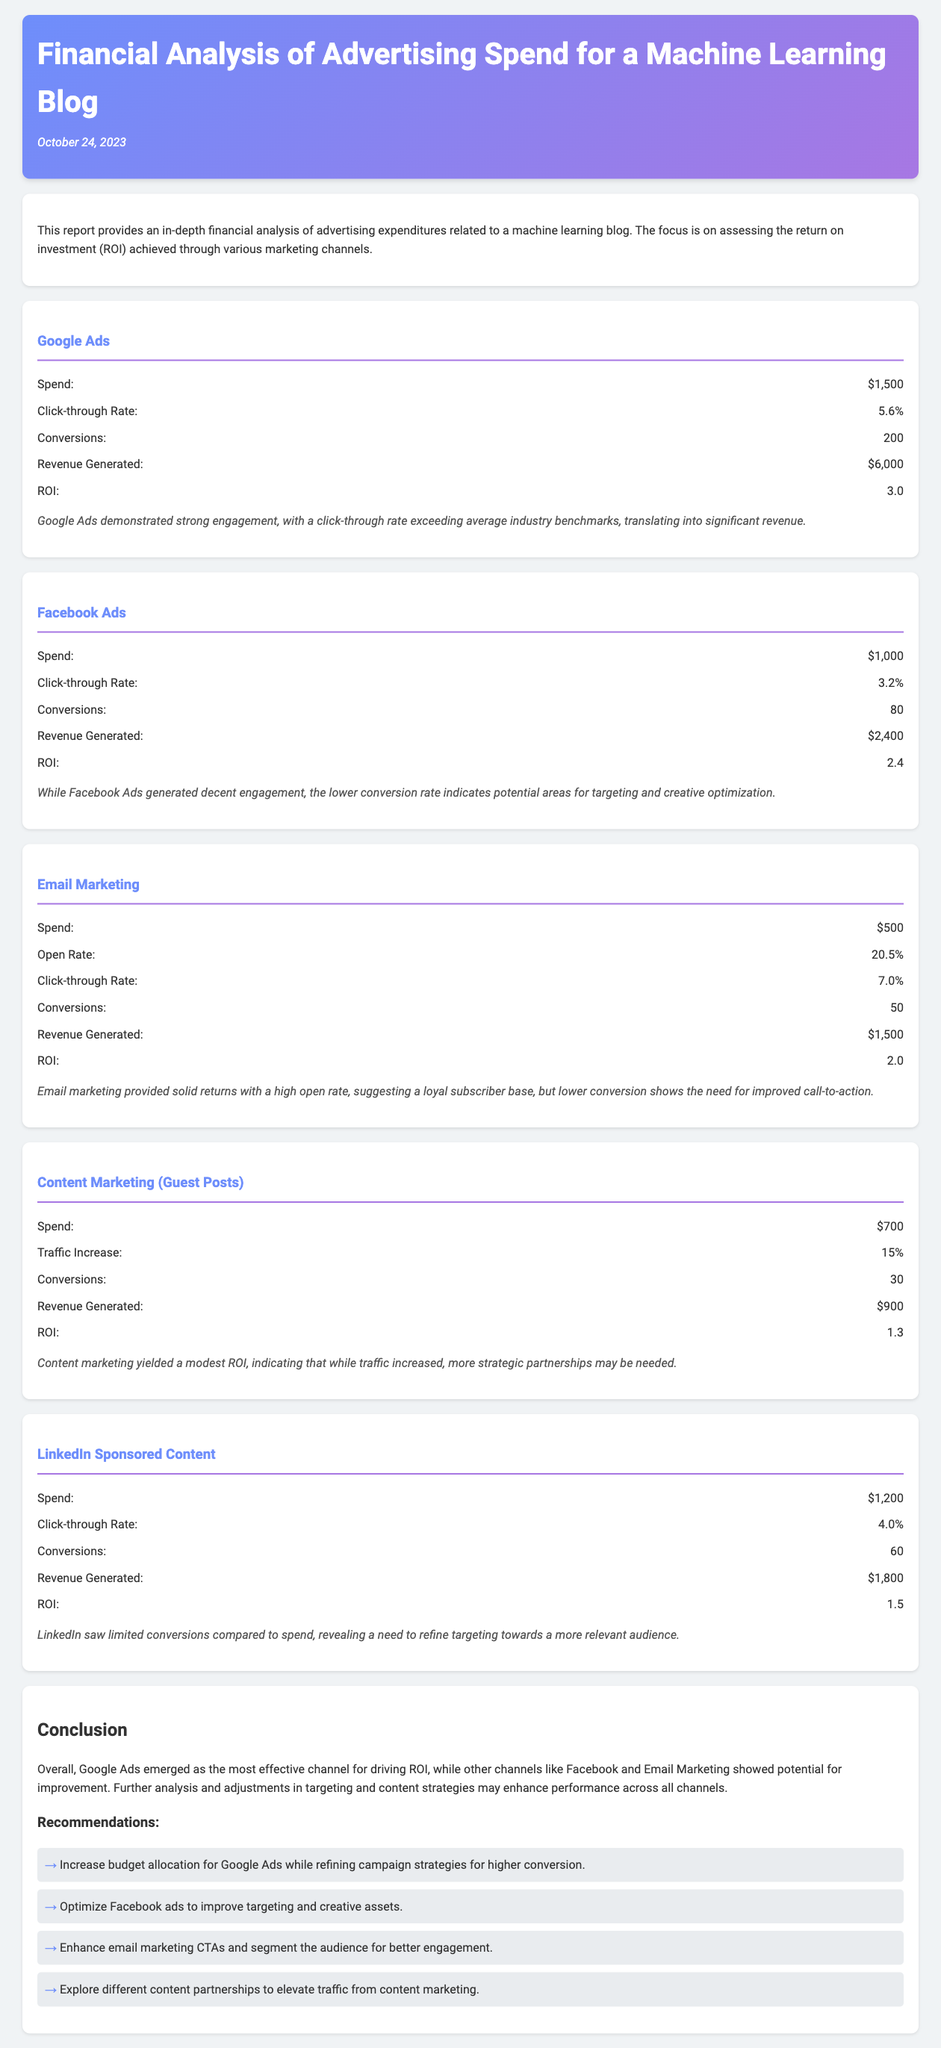What was the total spend on Google Ads? The total spend on Google Ads is stated directly in the document as $1,500.
Answer: $1,500 What is the ROI for Facebook Ads? The ROI for Facebook Ads is clearly specified in the document as 2.4.
Answer: 2.4 How much revenue did Email Marketing generate? The revenue generated from Email Marketing is provided in the document as $1,500.
Answer: $1,500 Which advertising channel had the highest click-through rate? The channel with the highest click-through rate is Google Ads, listed as 5.6%.
Answer: 5.6% What is the conversion number for LinkedIn Sponsored Content? The conversion number for LinkedIn Sponsored Content is given as 60 in the document.
Answer: 60 Which channel had the lowest ROI? The channel with the lowest ROI is Content Marketing (Guest Posts), stated as 1.3 in the report.
Answer: 1.3 What recommendation is made for Facebook Ads? The recommendation for Facebook Ads suggests to optimize targeting and creative assets.
Answer: Optimize targeting and creative assets What percentage traffic increase did Content Marketing achieve? The document notes a traffic increase of 15% from Content Marketing (Guest Posts).
Answer: 15% What was the total revenue generated from all channels? The total revenue is the sum of all revenue, which is $6,000 + $2,400 + $1,500 + $900 + $1,800 = $12,600.
Answer: $12,600 